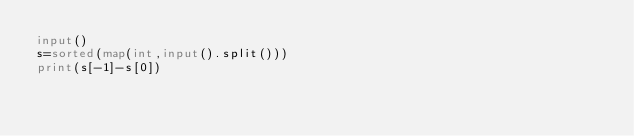<code> <loc_0><loc_0><loc_500><loc_500><_Python_>input()
s=sorted(map(int,input().split()))
print(s[-1]-s[0])</code> 